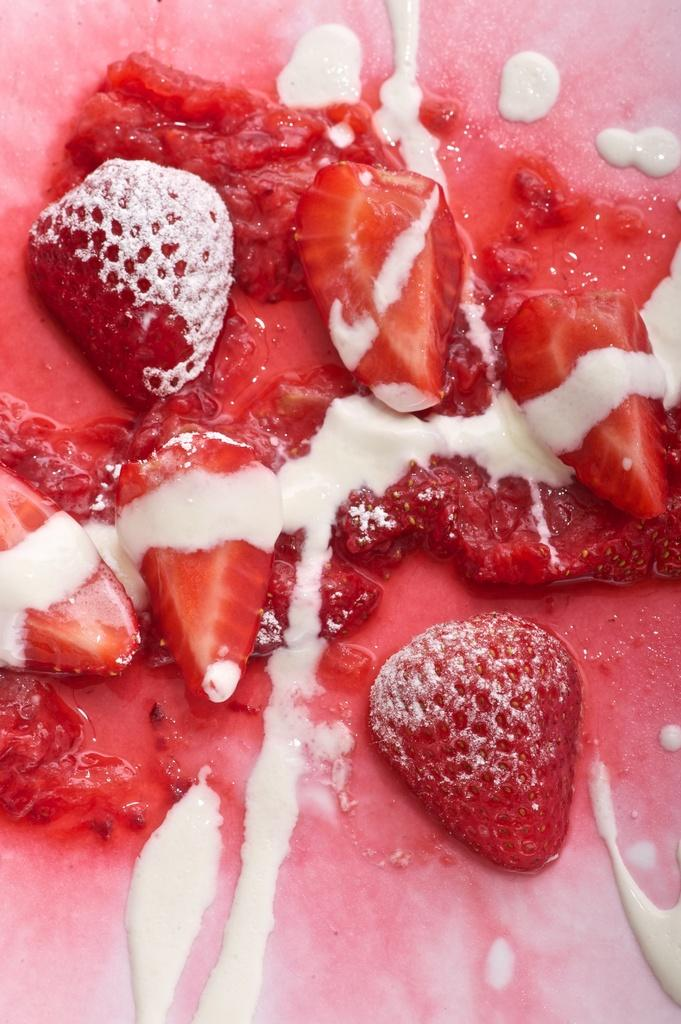What type of fruit can be seen in the image? There are strawberries in the image. What is the color of the cream in the image? The cream in the image is white. Where is the stove located in the image? There is no stove present in the image. What type of linen can be seen draped over the strawberries? There is no linen present in the image; it only features strawberries and white cream. 